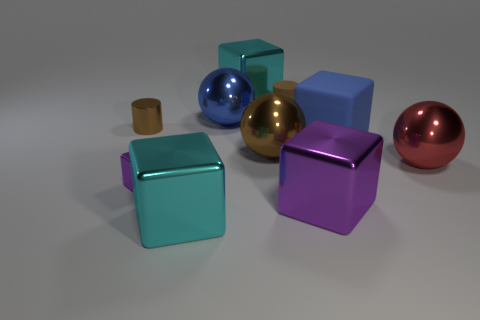Subtract 1 balls. How many balls are left? 2 Subtract all blue blocks. How many blocks are left? 4 Subtract all blue matte blocks. How many blocks are left? 4 Subtract all green blocks. Subtract all cyan cylinders. How many blocks are left? 5 Subtract all cylinders. How many objects are left? 8 Subtract 1 cyan cubes. How many objects are left? 9 Subtract all small brown metallic objects. Subtract all gray metal things. How many objects are left? 9 Add 2 cyan metal objects. How many cyan metal objects are left? 4 Add 10 large rubber cylinders. How many large rubber cylinders exist? 10 